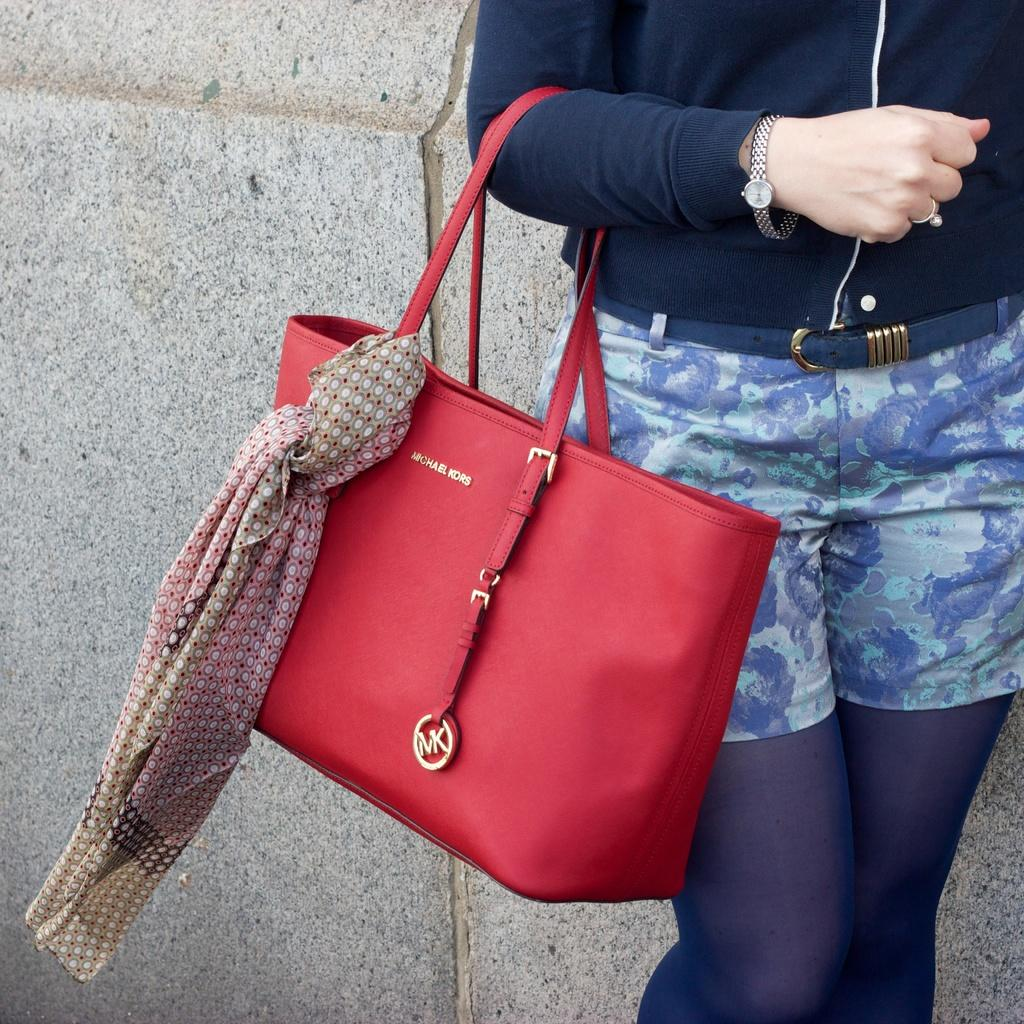Who is present in the image? There is a woman in the image. What is the woman carrying? The woman is carrying a handbag. Is there anything attached to the handbag? Yes, a cloth is tied to the handbag. What can be seen behind the woman? There is a wall behind the woman. How many boys are celebrating their birthday in the image? There are no boys or birthday celebrations present in the image. What type of sponge is being used to clean the wall in the image? There is no sponge or cleaning activity depicted in the image. 